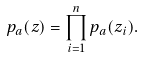<formula> <loc_0><loc_0><loc_500><loc_500>p _ { a } ( z ) = \prod _ { i = 1 } ^ { n } p _ { a } ( z _ { i } ) .</formula> 